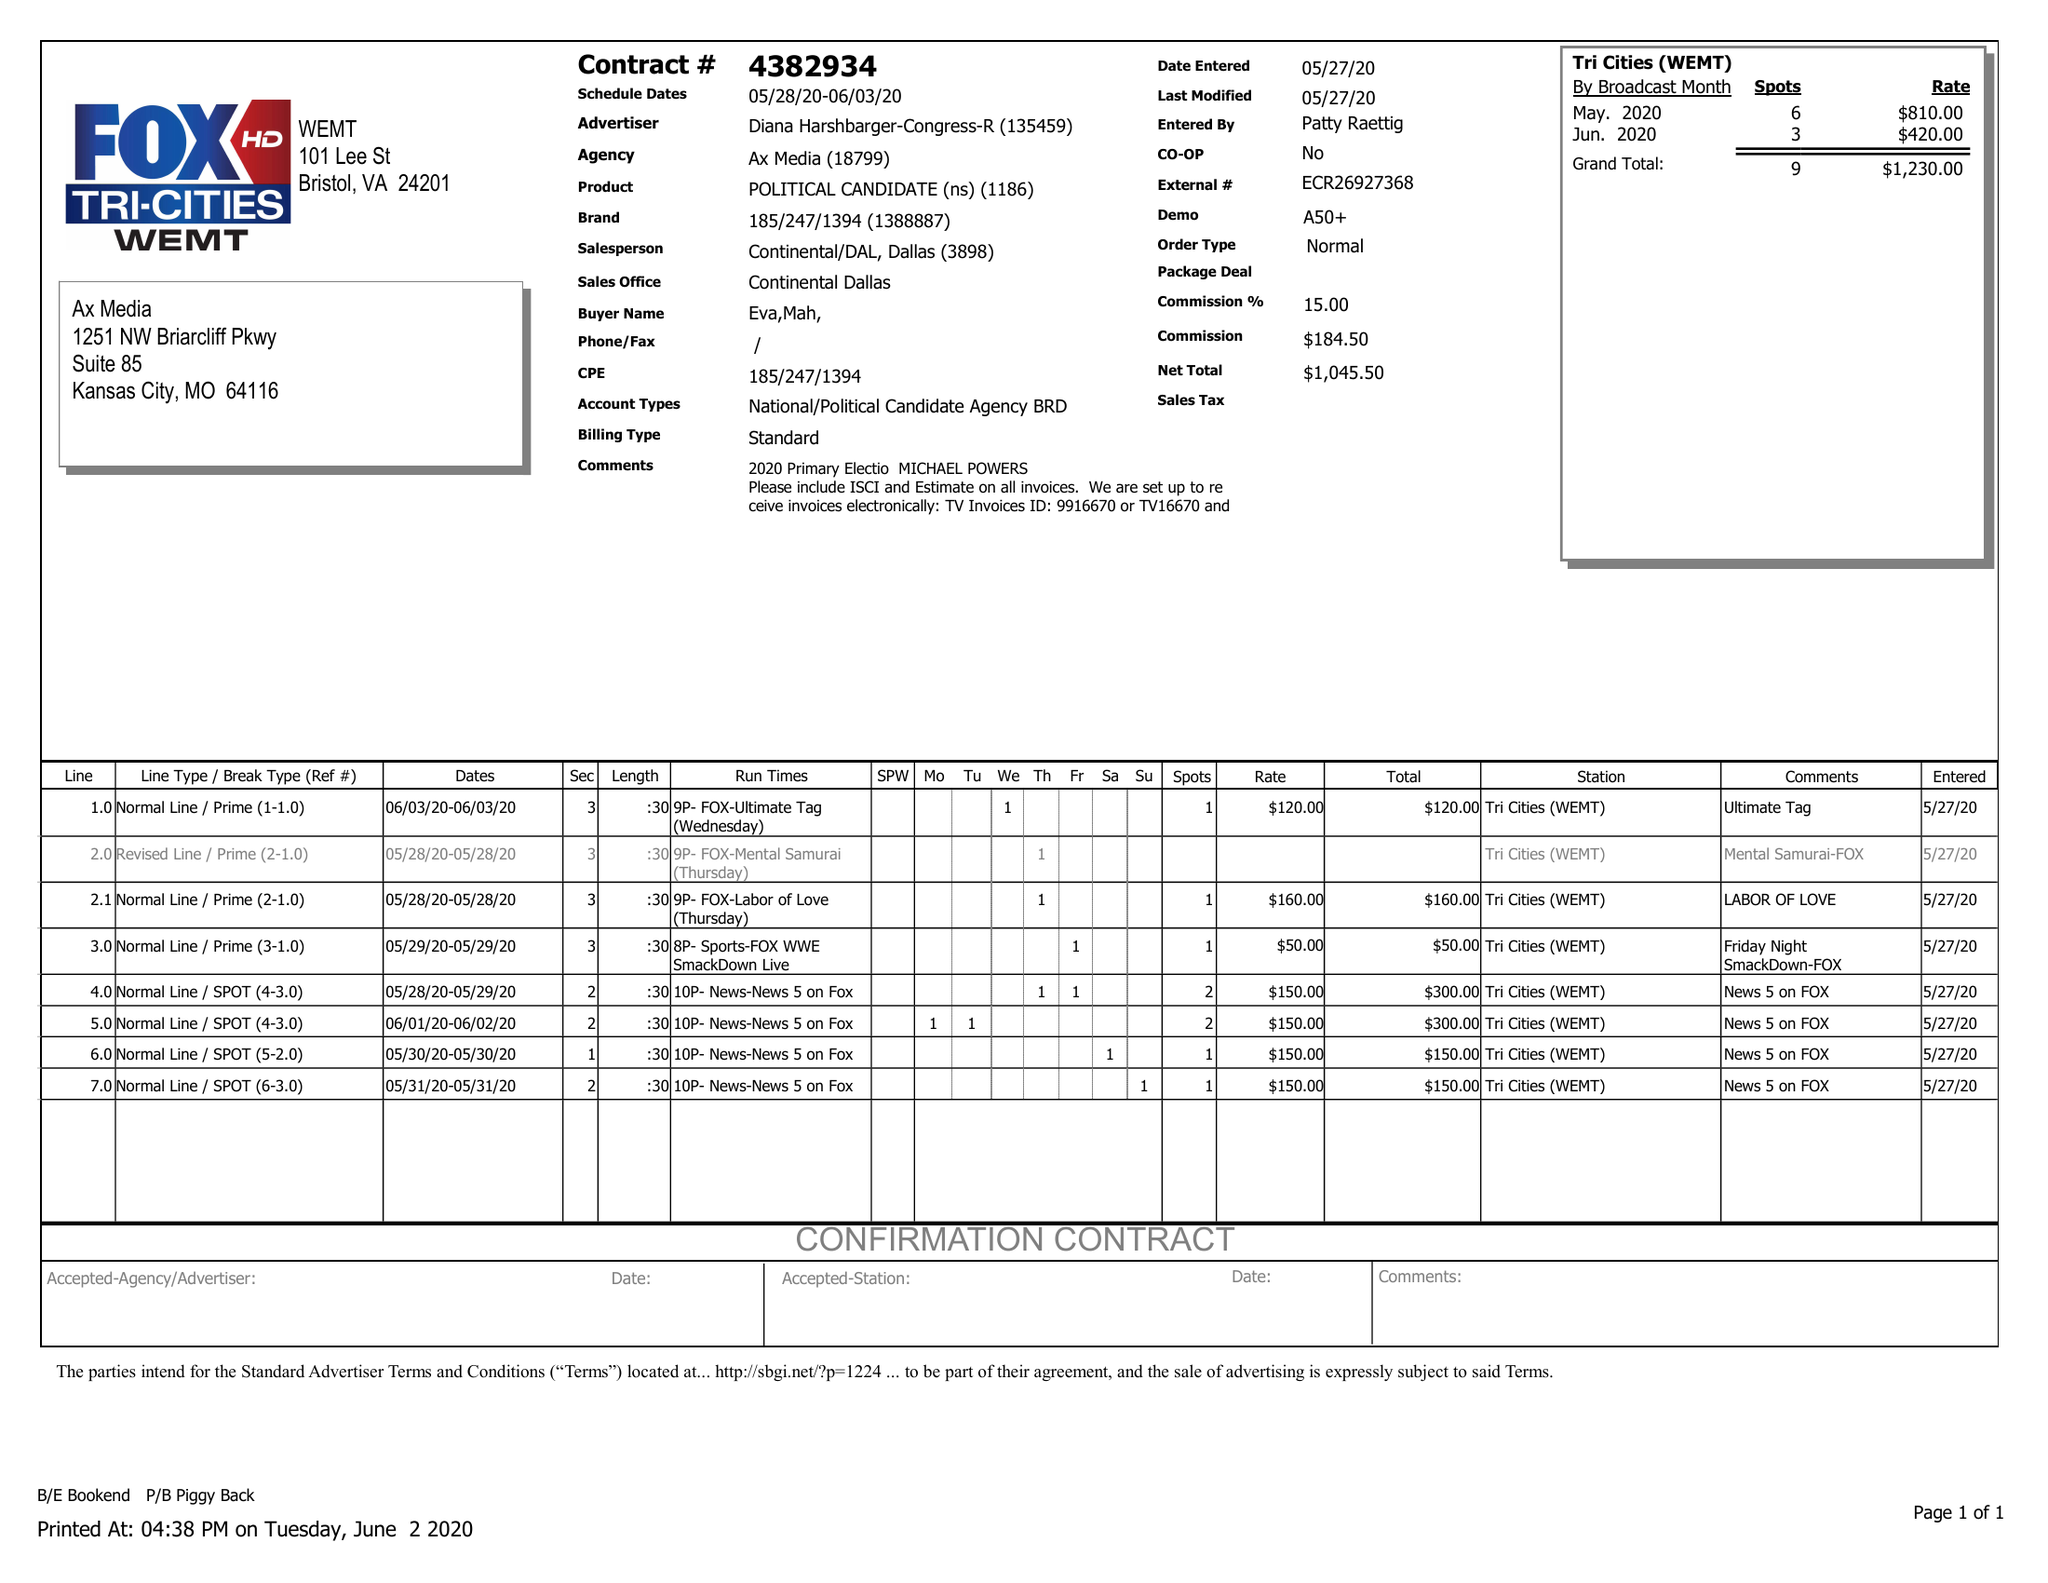What is the value for the flight_to?
Answer the question using a single word or phrase. 06/03/20 